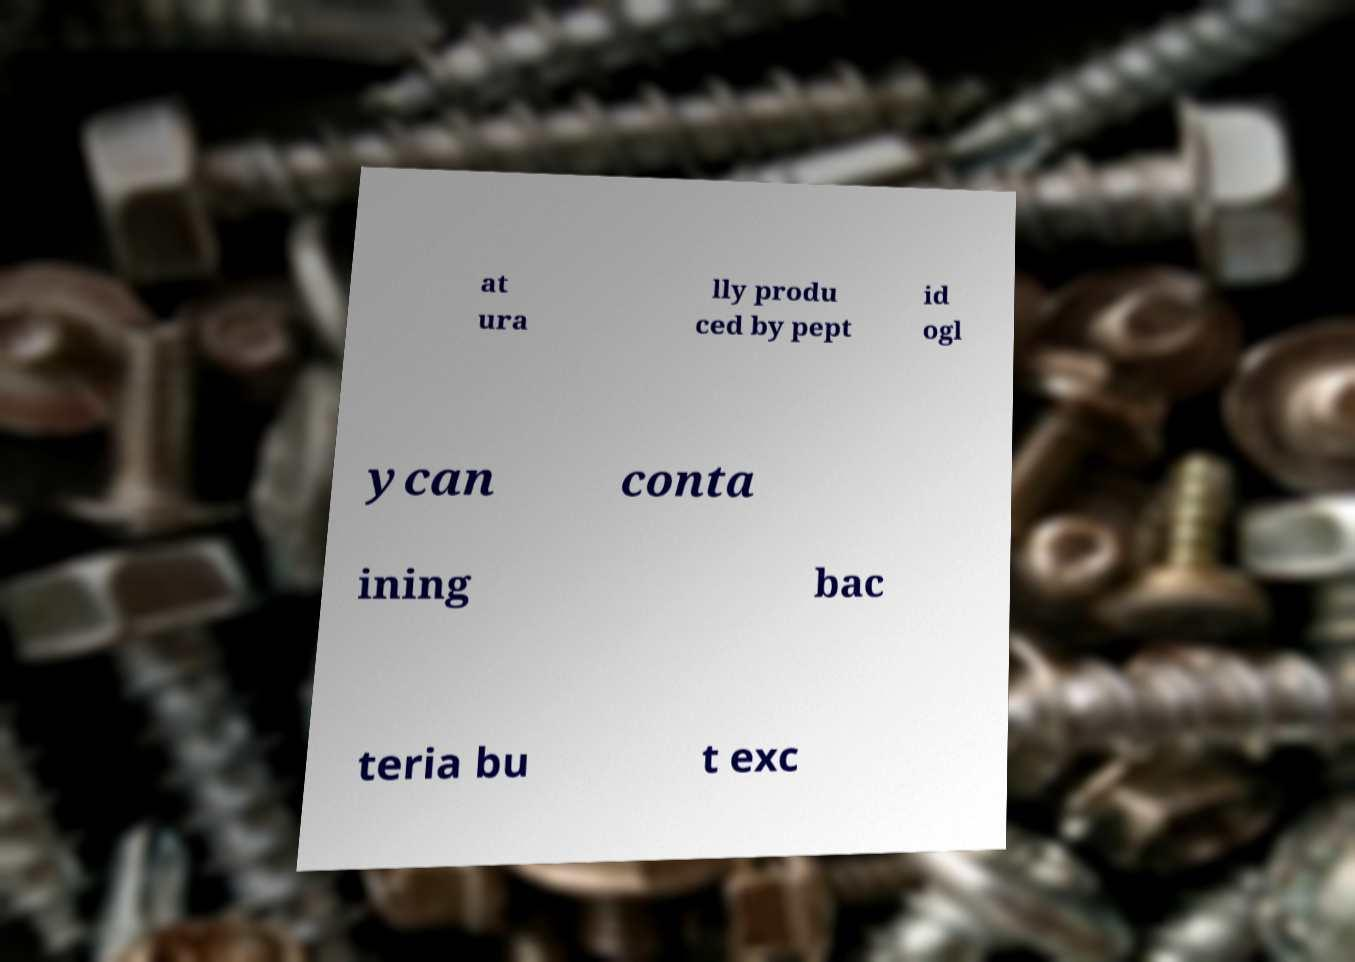I need the written content from this picture converted into text. Can you do that? at ura lly produ ced by pept id ogl ycan conta ining bac teria bu t exc 